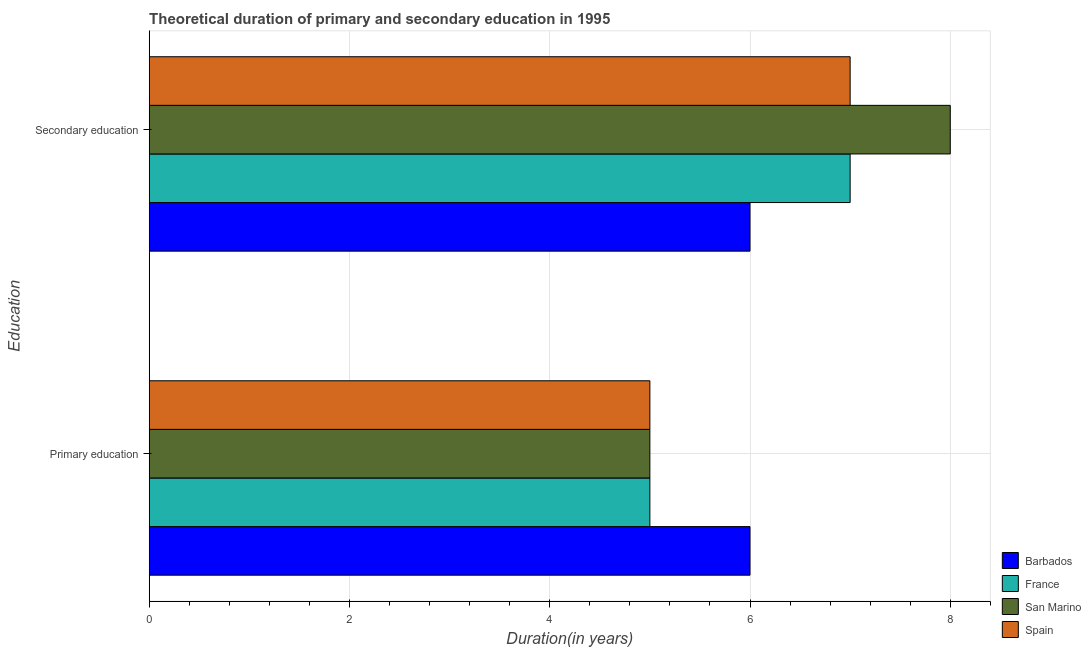How many different coloured bars are there?
Your answer should be very brief. 4. Are the number of bars on each tick of the Y-axis equal?
Ensure brevity in your answer.  Yes. How many bars are there on the 2nd tick from the top?
Give a very brief answer. 4. How many bars are there on the 2nd tick from the bottom?
Ensure brevity in your answer.  4. What is the duration of primary education in San Marino?
Ensure brevity in your answer.  5. Across all countries, what is the maximum duration of secondary education?
Give a very brief answer. 8. In which country was the duration of primary education maximum?
Provide a succinct answer. Barbados. What is the total duration of secondary education in the graph?
Offer a terse response. 28. What is the difference between the duration of primary education in Barbados and that in Spain?
Ensure brevity in your answer.  1. What is the difference between the duration of secondary education in Barbados and the duration of primary education in France?
Offer a very short reply. 1. What is the average duration of primary education per country?
Your answer should be very brief. 5.25. What is the ratio of the duration of primary education in France to that in Barbados?
Make the answer very short. 0.83. Is the duration of primary education in San Marino less than that in Barbados?
Provide a succinct answer. Yes. What does the 4th bar from the top in Primary education represents?
Make the answer very short. Barbados. How many bars are there?
Your response must be concise. 8. What is the difference between two consecutive major ticks on the X-axis?
Your response must be concise. 2. How many legend labels are there?
Keep it short and to the point. 4. How are the legend labels stacked?
Keep it short and to the point. Vertical. What is the title of the graph?
Keep it short and to the point. Theoretical duration of primary and secondary education in 1995. Does "Haiti" appear as one of the legend labels in the graph?
Your response must be concise. No. What is the label or title of the X-axis?
Provide a succinct answer. Duration(in years). What is the label or title of the Y-axis?
Offer a very short reply. Education. What is the Duration(in years) of Barbados in Primary education?
Give a very brief answer. 6. What is the Duration(in years) of France in Primary education?
Your answer should be compact. 5. What is the Duration(in years) in San Marino in Secondary education?
Provide a succinct answer. 8. Across all Education, what is the maximum Duration(in years) of France?
Give a very brief answer. 7. Across all Education, what is the maximum Duration(in years) in San Marino?
Give a very brief answer. 8. Across all Education, what is the maximum Duration(in years) in Spain?
Your answer should be very brief. 7. Across all Education, what is the minimum Duration(in years) in San Marino?
Provide a short and direct response. 5. Across all Education, what is the minimum Duration(in years) of Spain?
Offer a very short reply. 5. What is the total Duration(in years) in Barbados in the graph?
Provide a succinct answer. 12. What is the total Duration(in years) in Spain in the graph?
Your answer should be compact. 12. What is the difference between the Duration(in years) of France in Primary education and that in Secondary education?
Offer a very short reply. -2. What is the difference between the Duration(in years) in Spain in Primary education and that in Secondary education?
Your response must be concise. -2. What is the difference between the Duration(in years) of Barbados in Primary education and the Duration(in years) of France in Secondary education?
Your answer should be very brief. -1. What is the difference between the Duration(in years) of Barbados in Primary education and the Duration(in years) of San Marino in Secondary education?
Your answer should be compact. -2. What is the difference between the Duration(in years) of France in Primary education and the Duration(in years) of Spain in Secondary education?
Keep it short and to the point. -2. What is the average Duration(in years) in Barbados per Education?
Provide a short and direct response. 6. What is the average Duration(in years) in France per Education?
Ensure brevity in your answer.  6. What is the difference between the Duration(in years) in Barbados and Duration(in years) in France in Primary education?
Your response must be concise. 1. What is the difference between the Duration(in years) in Barbados and Duration(in years) in Spain in Primary education?
Provide a succinct answer. 1. What is the difference between the Duration(in years) of France and Duration(in years) of San Marino in Primary education?
Keep it short and to the point. 0. What is the difference between the Duration(in years) of France and Duration(in years) of Spain in Primary education?
Your answer should be very brief. 0. What is the difference between the Duration(in years) in Barbados and Duration(in years) in France in Secondary education?
Provide a short and direct response. -1. What is the difference between the Duration(in years) of France and Duration(in years) of San Marino in Secondary education?
Offer a very short reply. -1. What is the difference between the Duration(in years) in France and Duration(in years) in Spain in Secondary education?
Ensure brevity in your answer.  0. What is the ratio of the Duration(in years) in France in Primary education to that in Secondary education?
Offer a very short reply. 0.71. What is the difference between the highest and the second highest Duration(in years) in Barbados?
Your answer should be compact. 0. What is the difference between the highest and the second highest Duration(in years) of San Marino?
Your response must be concise. 3. 